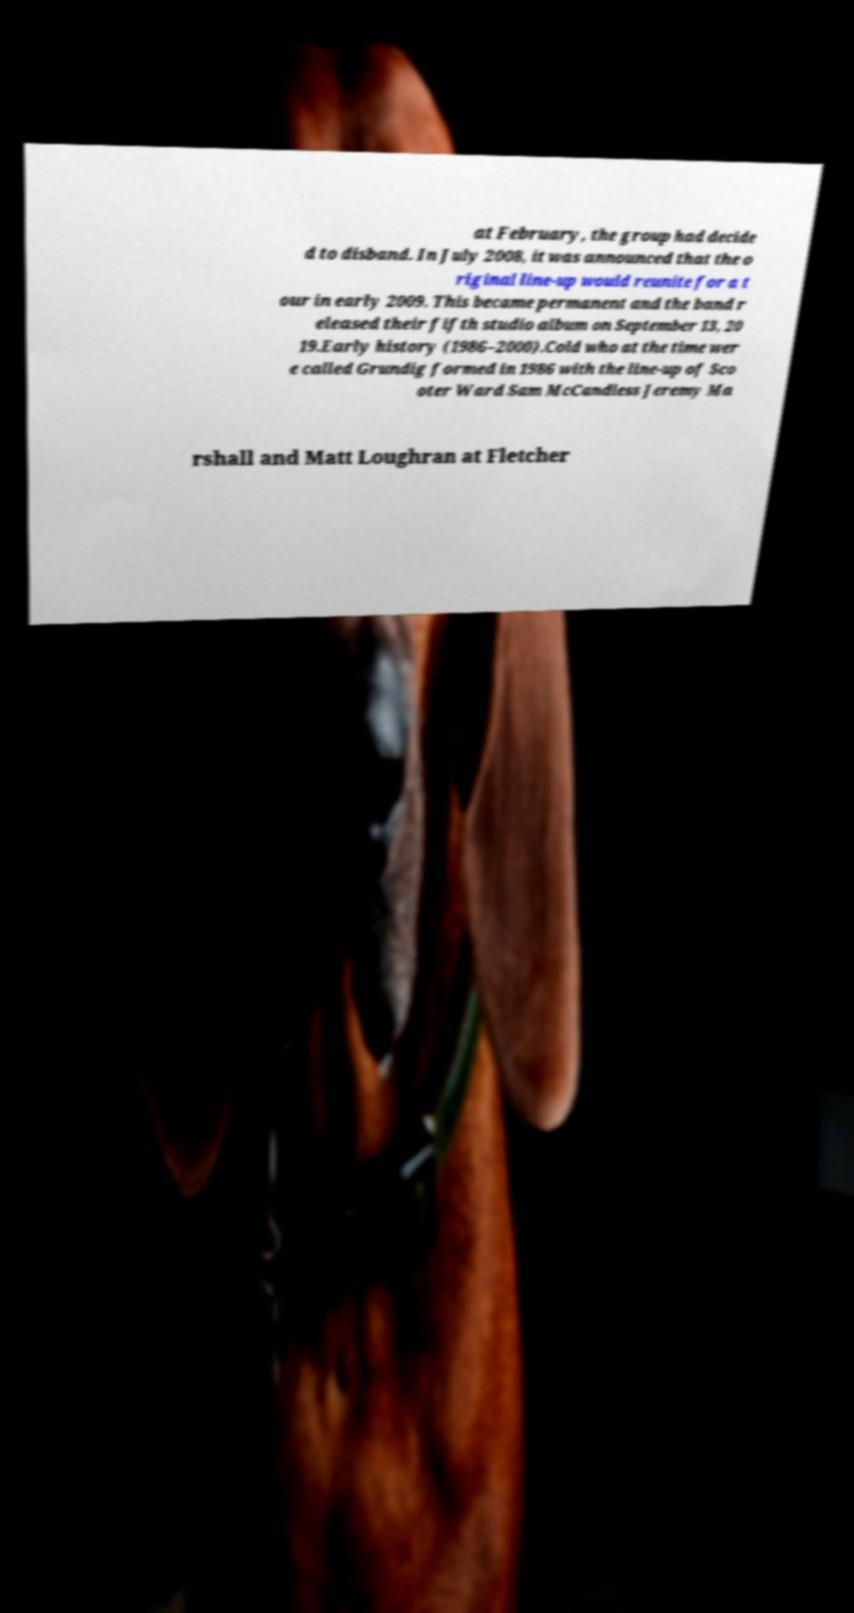Please read and relay the text visible in this image. What does it say? at February, the group had decide d to disband. In July 2008, it was announced that the o riginal line-up would reunite for a t our in early 2009. This became permanent and the band r eleased their fifth studio album on September 13, 20 19.Early history (1986–2000).Cold who at the time wer e called Grundig formed in 1986 with the line-up of Sco oter Ward Sam McCandless Jeremy Ma rshall and Matt Loughran at Fletcher 